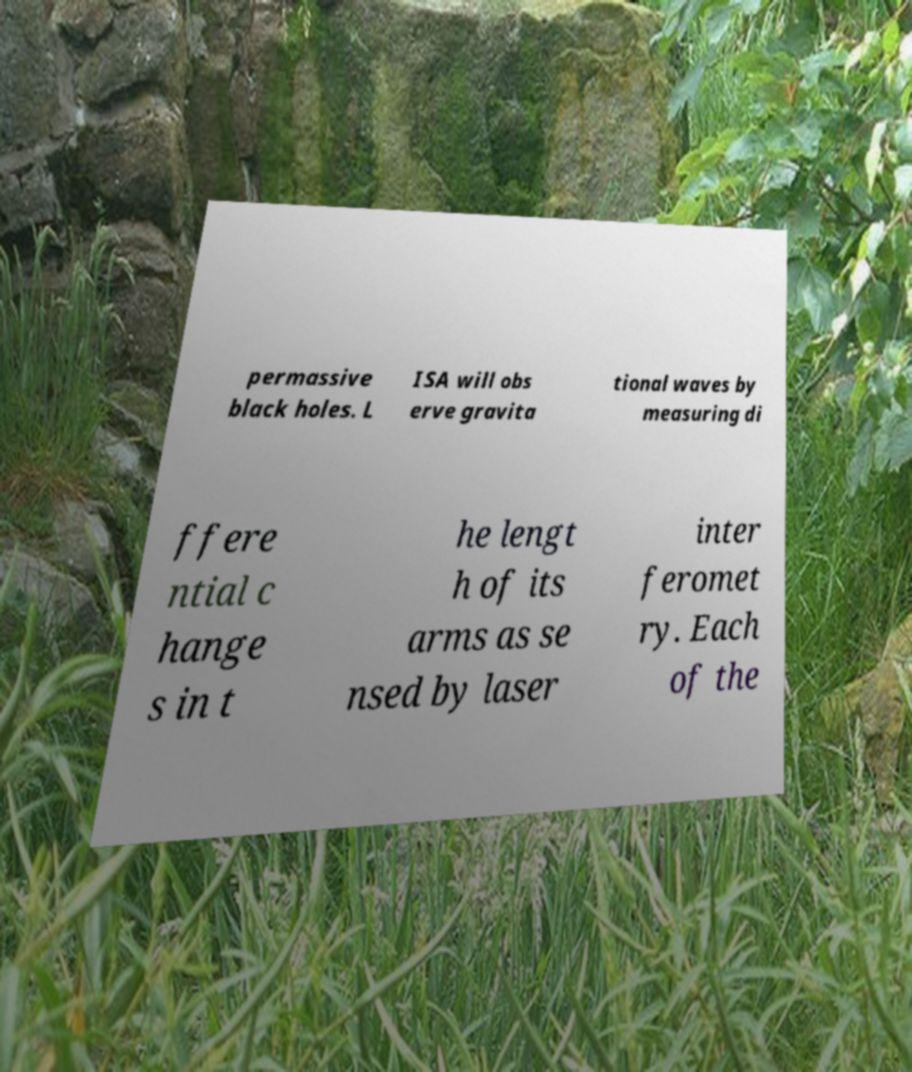Can you read and provide the text displayed in the image?This photo seems to have some interesting text. Can you extract and type it out for me? permassive black holes. L ISA will obs erve gravita tional waves by measuring di ffere ntial c hange s in t he lengt h of its arms as se nsed by laser inter feromet ry. Each of the 